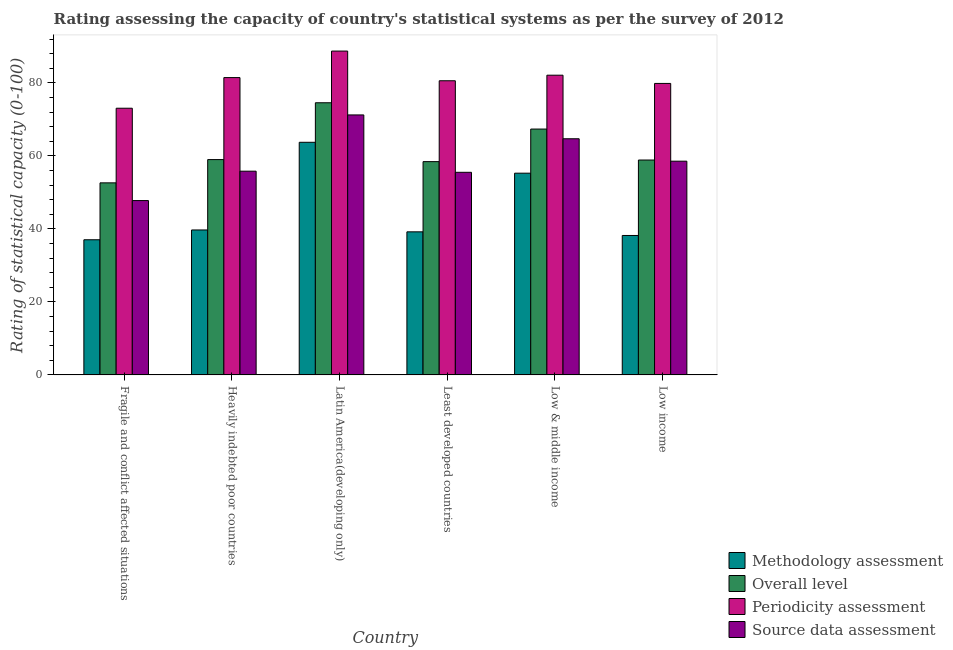How many groups of bars are there?
Provide a short and direct response. 6. How many bars are there on the 5th tick from the left?
Your response must be concise. 4. How many bars are there on the 3rd tick from the right?
Make the answer very short. 4. What is the methodology assessment rating in Least developed countries?
Your answer should be very brief. 39.21. Across all countries, what is the maximum overall level rating?
Offer a very short reply. 74.58. Across all countries, what is the minimum periodicity assessment rating?
Provide a succinct answer. 73.09. In which country was the overall level rating maximum?
Provide a succinct answer. Latin America(developing only). In which country was the periodicity assessment rating minimum?
Your response must be concise. Fragile and conflict affected situations. What is the total overall level rating in the graph?
Offer a terse response. 370.95. What is the difference between the methodology assessment rating in Fragile and conflict affected situations and that in Low & middle income?
Your answer should be very brief. -18.25. What is the difference between the methodology assessment rating in Low income and the overall level rating in Heavily indebted poor countries?
Offer a terse response. -20.8. What is the average overall level rating per country?
Ensure brevity in your answer.  61.82. What is the difference between the methodology assessment rating and source data assessment rating in Latin America(developing only)?
Your answer should be compact. -7.5. What is the ratio of the periodicity assessment rating in Heavily indebted poor countries to that in Latin America(developing only)?
Provide a short and direct response. 0.92. What is the difference between the highest and the second highest periodicity assessment rating?
Your answer should be very brief. 6.61. What is the difference between the highest and the lowest source data assessment rating?
Offer a terse response. 23.47. In how many countries, is the source data assessment rating greater than the average source data assessment rating taken over all countries?
Your answer should be very brief. 2. Is it the case that in every country, the sum of the overall level rating and methodology assessment rating is greater than the sum of source data assessment rating and periodicity assessment rating?
Offer a terse response. Yes. What does the 2nd bar from the left in Least developed countries represents?
Offer a very short reply. Overall level. What does the 3rd bar from the right in Heavily indebted poor countries represents?
Provide a succinct answer. Overall level. How many bars are there?
Keep it short and to the point. 24. How many countries are there in the graph?
Offer a very short reply. 6. What is the difference between two consecutive major ticks on the Y-axis?
Make the answer very short. 20. Does the graph contain any zero values?
Give a very brief answer. No. Does the graph contain grids?
Give a very brief answer. No. Where does the legend appear in the graph?
Provide a succinct answer. Bottom right. What is the title of the graph?
Your answer should be compact. Rating assessing the capacity of country's statistical systems as per the survey of 2012 . What is the label or title of the Y-axis?
Your answer should be very brief. Rating of statistical capacity (0-100). What is the Rating of statistical capacity (0-100) in Methodology assessment in Fragile and conflict affected situations?
Offer a very short reply. 37.04. What is the Rating of statistical capacity (0-100) of Overall level in Fragile and conflict affected situations?
Your answer should be very brief. 52.63. What is the Rating of statistical capacity (0-100) in Periodicity assessment in Fragile and conflict affected situations?
Provide a short and direct response. 73.09. What is the Rating of statistical capacity (0-100) of Source data assessment in Fragile and conflict affected situations?
Give a very brief answer. 47.78. What is the Rating of statistical capacity (0-100) of Methodology assessment in Heavily indebted poor countries?
Keep it short and to the point. 39.72. What is the Rating of statistical capacity (0-100) in Overall level in Heavily indebted poor countries?
Your answer should be compact. 59.01. What is the Rating of statistical capacity (0-100) in Periodicity assessment in Heavily indebted poor countries?
Your answer should be very brief. 81.48. What is the Rating of statistical capacity (0-100) in Source data assessment in Heavily indebted poor countries?
Your answer should be very brief. 55.83. What is the Rating of statistical capacity (0-100) of Methodology assessment in Latin America(developing only)?
Keep it short and to the point. 63.75. What is the Rating of statistical capacity (0-100) of Overall level in Latin America(developing only)?
Offer a terse response. 74.58. What is the Rating of statistical capacity (0-100) in Periodicity assessment in Latin America(developing only)?
Offer a terse response. 88.75. What is the Rating of statistical capacity (0-100) in Source data assessment in Latin America(developing only)?
Your response must be concise. 71.25. What is the Rating of statistical capacity (0-100) of Methodology assessment in Least developed countries?
Offer a terse response. 39.21. What is the Rating of statistical capacity (0-100) of Overall level in Least developed countries?
Your response must be concise. 58.45. What is the Rating of statistical capacity (0-100) of Periodicity assessment in Least developed countries?
Keep it short and to the point. 80.61. What is the Rating of statistical capacity (0-100) in Source data assessment in Least developed countries?
Provide a short and direct response. 55.53. What is the Rating of statistical capacity (0-100) of Methodology assessment in Low & middle income?
Your answer should be very brief. 55.28. What is the Rating of statistical capacity (0-100) of Overall level in Low & middle income?
Your answer should be very brief. 67.38. What is the Rating of statistical capacity (0-100) of Periodicity assessment in Low & middle income?
Your response must be concise. 82.14. What is the Rating of statistical capacity (0-100) in Source data assessment in Low & middle income?
Offer a terse response. 64.72. What is the Rating of statistical capacity (0-100) of Methodology assessment in Low income?
Make the answer very short. 38.21. What is the Rating of statistical capacity (0-100) in Overall level in Low income?
Keep it short and to the point. 58.89. What is the Rating of statistical capacity (0-100) in Periodicity assessment in Low income?
Offer a terse response. 79.88. What is the Rating of statistical capacity (0-100) of Source data assessment in Low income?
Provide a succinct answer. 58.57. Across all countries, what is the maximum Rating of statistical capacity (0-100) of Methodology assessment?
Your answer should be compact. 63.75. Across all countries, what is the maximum Rating of statistical capacity (0-100) of Overall level?
Your answer should be compact. 74.58. Across all countries, what is the maximum Rating of statistical capacity (0-100) in Periodicity assessment?
Provide a short and direct response. 88.75. Across all countries, what is the maximum Rating of statistical capacity (0-100) of Source data assessment?
Your answer should be very brief. 71.25. Across all countries, what is the minimum Rating of statistical capacity (0-100) in Methodology assessment?
Offer a very short reply. 37.04. Across all countries, what is the minimum Rating of statistical capacity (0-100) of Overall level?
Your response must be concise. 52.63. Across all countries, what is the minimum Rating of statistical capacity (0-100) of Periodicity assessment?
Provide a short and direct response. 73.09. Across all countries, what is the minimum Rating of statistical capacity (0-100) in Source data assessment?
Offer a terse response. 47.78. What is the total Rating of statistical capacity (0-100) of Methodology assessment in the graph?
Keep it short and to the point. 273.22. What is the total Rating of statistical capacity (0-100) of Overall level in the graph?
Provide a short and direct response. 370.95. What is the total Rating of statistical capacity (0-100) of Periodicity assessment in the graph?
Offer a very short reply. 485.95. What is the total Rating of statistical capacity (0-100) of Source data assessment in the graph?
Your answer should be very brief. 353.68. What is the difference between the Rating of statistical capacity (0-100) in Methodology assessment in Fragile and conflict affected situations and that in Heavily indebted poor countries?
Your response must be concise. -2.69. What is the difference between the Rating of statistical capacity (0-100) in Overall level in Fragile and conflict affected situations and that in Heavily indebted poor countries?
Provide a succinct answer. -6.38. What is the difference between the Rating of statistical capacity (0-100) in Periodicity assessment in Fragile and conflict affected situations and that in Heavily indebted poor countries?
Your answer should be very brief. -8.4. What is the difference between the Rating of statistical capacity (0-100) in Source data assessment in Fragile and conflict affected situations and that in Heavily indebted poor countries?
Keep it short and to the point. -8.06. What is the difference between the Rating of statistical capacity (0-100) of Methodology assessment in Fragile and conflict affected situations and that in Latin America(developing only)?
Provide a succinct answer. -26.71. What is the difference between the Rating of statistical capacity (0-100) in Overall level in Fragile and conflict affected situations and that in Latin America(developing only)?
Make the answer very short. -21.95. What is the difference between the Rating of statistical capacity (0-100) of Periodicity assessment in Fragile and conflict affected situations and that in Latin America(developing only)?
Provide a succinct answer. -15.66. What is the difference between the Rating of statistical capacity (0-100) of Source data assessment in Fragile and conflict affected situations and that in Latin America(developing only)?
Your answer should be very brief. -23.47. What is the difference between the Rating of statistical capacity (0-100) in Methodology assessment in Fragile and conflict affected situations and that in Least developed countries?
Keep it short and to the point. -2.17. What is the difference between the Rating of statistical capacity (0-100) in Overall level in Fragile and conflict affected situations and that in Least developed countries?
Ensure brevity in your answer.  -5.82. What is the difference between the Rating of statistical capacity (0-100) of Periodicity assessment in Fragile and conflict affected situations and that in Least developed countries?
Your response must be concise. -7.53. What is the difference between the Rating of statistical capacity (0-100) of Source data assessment in Fragile and conflict affected situations and that in Least developed countries?
Make the answer very short. -7.75. What is the difference between the Rating of statistical capacity (0-100) in Methodology assessment in Fragile and conflict affected situations and that in Low & middle income?
Your answer should be very brief. -18.25. What is the difference between the Rating of statistical capacity (0-100) in Overall level in Fragile and conflict affected situations and that in Low & middle income?
Keep it short and to the point. -14.75. What is the difference between the Rating of statistical capacity (0-100) of Periodicity assessment in Fragile and conflict affected situations and that in Low & middle income?
Offer a very short reply. -9.05. What is the difference between the Rating of statistical capacity (0-100) in Source data assessment in Fragile and conflict affected situations and that in Low & middle income?
Offer a terse response. -16.94. What is the difference between the Rating of statistical capacity (0-100) in Methodology assessment in Fragile and conflict affected situations and that in Low income?
Offer a terse response. -1.18. What is the difference between the Rating of statistical capacity (0-100) of Overall level in Fragile and conflict affected situations and that in Low income?
Your answer should be compact. -6.26. What is the difference between the Rating of statistical capacity (0-100) of Periodicity assessment in Fragile and conflict affected situations and that in Low income?
Offer a very short reply. -6.79. What is the difference between the Rating of statistical capacity (0-100) in Source data assessment in Fragile and conflict affected situations and that in Low income?
Make the answer very short. -10.79. What is the difference between the Rating of statistical capacity (0-100) in Methodology assessment in Heavily indebted poor countries and that in Latin America(developing only)?
Your response must be concise. -24.03. What is the difference between the Rating of statistical capacity (0-100) in Overall level in Heavily indebted poor countries and that in Latin America(developing only)?
Offer a very short reply. -15.57. What is the difference between the Rating of statistical capacity (0-100) in Periodicity assessment in Heavily indebted poor countries and that in Latin America(developing only)?
Your answer should be very brief. -7.27. What is the difference between the Rating of statistical capacity (0-100) of Source data assessment in Heavily indebted poor countries and that in Latin America(developing only)?
Give a very brief answer. -15.42. What is the difference between the Rating of statistical capacity (0-100) in Methodology assessment in Heavily indebted poor countries and that in Least developed countries?
Offer a terse response. 0.51. What is the difference between the Rating of statistical capacity (0-100) of Overall level in Heavily indebted poor countries and that in Least developed countries?
Give a very brief answer. 0.56. What is the difference between the Rating of statistical capacity (0-100) of Periodicity assessment in Heavily indebted poor countries and that in Least developed countries?
Provide a short and direct response. 0.87. What is the difference between the Rating of statistical capacity (0-100) in Source data assessment in Heavily indebted poor countries and that in Least developed countries?
Offer a terse response. 0.31. What is the difference between the Rating of statistical capacity (0-100) in Methodology assessment in Heavily indebted poor countries and that in Low & middle income?
Offer a terse response. -15.56. What is the difference between the Rating of statistical capacity (0-100) in Overall level in Heavily indebted poor countries and that in Low & middle income?
Offer a terse response. -8.37. What is the difference between the Rating of statistical capacity (0-100) in Periodicity assessment in Heavily indebted poor countries and that in Low & middle income?
Your answer should be compact. -0.66. What is the difference between the Rating of statistical capacity (0-100) of Source data assessment in Heavily indebted poor countries and that in Low & middle income?
Ensure brevity in your answer.  -8.88. What is the difference between the Rating of statistical capacity (0-100) in Methodology assessment in Heavily indebted poor countries and that in Low income?
Make the answer very short. 1.51. What is the difference between the Rating of statistical capacity (0-100) in Overall level in Heavily indebted poor countries and that in Low income?
Your answer should be very brief. 0.12. What is the difference between the Rating of statistical capacity (0-100) of Periodicity assessment in Heavily indebted poor countries and that in Low income?
Offer a very short reply. 1.6. What is the difference between the Rating of statistical capacity (0-100) in Source data assessment in Heavily indebted poor countries and that in Low income?
Your response must be concise. -2.74. What is the difference between the Rating of statistical capacity (0-100) of Methodology assessment in Latin America(developing only) and that in Least developed countries?
Your answer should be compact. 24.54. What is the difference between the Rating of statistical capacity (0-100) in Overall level in Latin America(developing only) and that in Least developed countries?
Your answer should be compact. 16.13. What is the difference between the Rating of statistical capacity (0-100) in Periodicity assessment in Latin America(developing only) and that in Least developed countries?
Your response must be concise. 8.14. What is the difference between the Rating of statistical capacity (0-100) of Source data assessment in Latin America(developing only) and that in Least developed countries?
Provide a short and direct response. 15.72. What is the difference between the Rating of statistical capacity (0-100) in Methodology assessment in Latin America(developing only) and that in Low & middle income?
Give a very brief answer. 8.47. What is the difference between the Rating of statistical capacity (0-100) of Overall level in Latin America(developing only) and that in Low & middle income?
Ensure brevity in your answer.  7.2. What is the difference between the Rating of statistical capacity (0-100) of Periodicity assessment in Latin America(developing only) and that in Low & middle income?
Your answer should be compact. 6.61. What is the difference between the Rating of statistical capacity (0-100) of Source data assessment in Latin America(developing only) and that in Low & middle income?
Give a very brief answer. 6.53. What is the difference between the Rating of statistical capacity (0-100) in Methodology assessment in Latin America(developing only) and that in Low income?
Keep it short and to the point. 25.54. What is the difference between the Rating of statistical capacity (0-100) in Overall level in Latin America(developing only) and that in Low income?
Provide a short and direct response. 15.69. What is the difference between the Rating of statistical capacity (0-100) of Periodicity assessment in Latin America(developing only) and that in Low income?
Your answer should be compact. 8.87. What is the difference between the Rating of statistical capacity (0-100) in Source data assessment in Latin America(developing only) and that in Low income?
Give a very brief answer. 12.68. What is the difference between the Rating of statistical capacity (0-100) of Methodology assessment in Least developed countries and that in Low & middle income?
Your answer should be very brief. -16.07. What is the difference between the Rating of statistical capacity (0-100) in Overall level in Least developed countries and that in Low & middle income?
Ensure brevity in your answer.  -8.93. What is the difference between the Rating of statistical capacity (0-100) in Periodicity assessment in Least developed countries and that in Low & middle income?
Provide a succinct answer. -1.52. What is the difference between the Rating of statistical capacity (0-100) of Source data assessment in Least developed countries and that in Low & middle income?
Your answer should be compact. -9.19. What is the difference between the Rating of statistical capacity (0-100) in Overall level in Least developed countries and that in Low income?
Offer a terse response. -0.44. What is the difference between the Rating of statistical capacity (0-100) in Periodicity assessment in Least developed countries and that in Low income?
Make the answer very short. 0.73. What is the difference between the Rating of statistical capacity (0-100) of Source data assessment in Least developed countries and that in Low income?
Offer a terse response. -3.05. What is the difference between the Rating of statistical capacity (0-100) in Methodology assessment in Low & middle income and that in Low income?
Your answer should be very brief. 17.07. What is the difference between the Rating of statistical capacity (0-100) in Overall level in Low & middle income and that in Low income?
Ensure brevity in your answer.  8.49. What is the difference between the Rating of statistical capacity (0-100) of Periodicity assessment in Low & middle income and that in Low income?
Provide a succinct answer. 2.26. What is the difference between the Rating of statistical capacity (0-100) in Source data assessment in Low & middle income and that in Low income?
Offer a terse response. 6.15. What is the difference between the Rating of statistical capacity (0-100) of Methodology assessment in Fragile and conflict affected situations and the Rating of statistical capacity (0-100) of Overall level in Heavily indebted poor countries?
Your answer should be compact. -21.98. What is the difference between the Rating of statistical capacity (0-100) in Methodology assessment in Fragile and conflict affected situations and the Rating of statistical capacity (0-100) in Periodicity assessment in Heavily indebted poor countries?
Ensure brevity in your answer.  -44.44. What is the difference between the Rating of statistical capacity (0-100) in Methodology assessment in Fragile and conflict affected situations and the Rating of statistical capacity (0-100) in Source data assessment in Heavily indebted poor countries?
Your answer should be very brief. -18.8. What is the difference between the Rating of statistical capacity (0-100) in Overall level in Fragile and conflict affected situations and the Rating of statistical capacity (0-100) in Periodicity assessment in Heavily indebted poor countries?
Offer a terse response. -28.85. What is the difference between the Rating of statistical capacity (0-100) of Overall level in Fragile and conflict affected situations and the Rating of statistical capacity (0-100) of Source data assessment in Heavily indebted poor countries?
Make the answer very short. -3.2. What is the difference between the Rating of statistical capacity (0-100) in Periodicity assessment in Fragile and conflict affected situations and the Rating of statistical capacity (0-100) in Source data assessment in Heavily indebted poor countries?
Ensure brevity in your answer.  17.25. What is the difference between the Rating of statistical capacity (0-100) in Methodology assessment in Fragile and conflict affected situations and the Rating of statistical capacity (0-100) in Overall level in Latin America(developing only)?
Offer a very short reply. -37.55. What is the difference between the Rating of statistical capacity (0-100) of Methodology assessment in Fragile and conflict affected situations and the Rating of statistical capacity (0-100) of Periodicity assessment in Latin America(developing only)?
Keep it short and to the point. -51.71. What is the difference between the Rating of statistical capacity (0-100) of Methodology assessment in Fragile and conflict affected situations and the Rating of statistical capacity (0-100) of Source data assessment in Latin America(developing only)?
Offer a terse response. -34.21. What is the difference between the Rating of statistical capacity (0-100) of Overall level in Fragile and conflict affected situations and the Rating of statistical capacity (0-100) of Periodicity assessment in Latin America(developing only)?
Offer a terse response. -36.12. What is the difference between the Rating of statistical capacity (0-100) in Overall level in Fragile and conflict affected situations and the Rating of statistical capacity (0-100) in Source data assessment in Latin America(developing only)?
Provide a short and direct response. -18.62. What is the difference between the Rating of statistical capacity (0-100) of Periodicity assessment in Fragile and conflict affected situations and the Rating of statistical capacity (0-100) of Source data assessment in Latin America(developing only)?
Provide a succinct answer. 1.84. What is the difference between the Rating of statistical capacity (0-100) in Methodology assessment in Fragile and conflict affected situations and the Rating of statistical capacity (0-100) in Overall level in Least developed countries?
Ensure brevity in your answer.  -21.41. What is the difference between the Rating of statistical capacity (0-100) of Methodology assessment in Fragile and conflict affected situations and the Rating of statistical capacity (0-100) of Periodicity assessment in Least developed countries?
Provide a short and direct response. -43.58. What is the difference between the Rating of statistical capacity (0-100) in Methodology assessment in Fragile and conflict affected situations and the Rating of statistical capacity (0-100) in Source data assessment in Least developed countries?
Provide a succinct answer. -18.49. What is the difference between the Rating of statistical capacity (0-100) in Overall level in Fragile and conflict affected situations and the Rating of statistical capacity (0-100) in Periodicity assessment in Least developed countries?
Keep it short and to the point. -27.98. What is the difference between the Rating of statistical capacity (0-100) in Overall level in Fragile and conflict affected situations and the Rating of statistical capacity (0-100) in Source data assessment in Least developed countries?
Ensure brevity in your answer.  -2.89. What is the difference between the Rating of statistical capacity (0-100) in Periodicity assessment in Fragile and conflict affected situations and the Rating of statistical capacity (0-100) in Source data assessment in Least developed countries?
Provide a succinct answer. 17.56. What is the difference between the Rating of statistical capacity (0-100) of Methodology assessment in Fragile and conflict affected situations and the Rating of statistical capacity (0-100) of Overall level in Low & middle income?
Give a very brief answer. -30.34. What is the difference between the Rating of statistical capacity (0-100) in Methodology assessment in Fragile and conflict affected situations and the Rating of statistical capacity (0-100) in Periodicity assessment in Low & middle income?
Your response must be concise. -45.1. What is the difference between the Rating of statistical capacity (0-100) of Methodology assessment in Fragile and conflict affected situations and the Rating of statistical capacity (0-100) of Source data assessment in Low & middle income?
Offer a very short reply. -27.68. What is the difference between the Rating of statistical capacity (0-100) in Overall level in Fragile and conflict affected situations and the Rating of statistical capacity (0-100) in Periodicity assessment in Low & middle income?
Make the answer very short. -29.5. What is the difference between the Rating of statistical capacity (0-100) of Overall level in Fragile and conflict affected situations and the Rating of statistical capacity (0-100) of Source data assessment in Low & middle income?
Your response must be concise. -12.08. What is the difference between the Rating of statistical capacity (0-100) of Periodicity assessment in Fragile and conflict affected situations and the Rating of statistical capacity (0-100) of Source data assessment in Low & middle income?
Provide a short and direct response. 8.37. What is the difference between the Rating of statistical capacity (0-100) of Methodology assessment in Fragile and conflict affected situations and the Rating of statistical capacity (0-100) of Overall level in Low income?
Provide a succinct answer. -21.85. What is the difference between the Rating of statistical capacity (0-100) of Methodology assessment in Fragile and conflict affected situations and the Rating of statistical capacity (0-100) of Periodicity assessment in Low income?
Offer a terse response. -42.84. What is the difference between the Rating of statistical capacity (0-100) of Methodology assessment in Fragile and conflict affected situations and the Rating of statistical capacity (0-100) of Source data assessment in Low income?
Your response must be concise. -21.53. What is the difference between the Rating of statistical capacity (0-100) of Overall level in Fragile and conflict affected situations and the Rating of statistical capacity (0-100) of Periodicity assessment in Low income?
Your answer should be very brief. -27.25. What is the difference between the Rating of statistical capacity (0-100) in Overall level in Fragile and conflict affected situations and the Rating of statistical capacity (0-100) in Source data assessment in Low income?
Keep it short and to the point. -5.94. What is the difference between the Rating of statistical capacity (0-100) in Periodicity assessment in Fragile and conflict affected situations and the Rating of statistical capacity (0-100) in Source data assessment in Low income?
Offer a very short reply. 14.52. What is the difference between the Rating of statistical capacity (0-100) in Methodology assessment in Heavily indebted poor countries and the Rating of statistical capacity (0-100) in Overall level in Latin America(developing only)?
Provide a succinct answer. -34.86. What is the difference between the Rating of statistical capacity (0-100) of Methodology assessment in Heavily indebted poor countries and the Rating of statistical capacity (0-100) of Periodicity assessment in Latin America(developing only)?
Give a very brief answer. -49.03. What is the difference between the Rating of statistical capacity (0-100) of Methodology assessment in Heavily indebted poor countries and the Rating of statistical capacity (0-100) of Source data assessment in Latin America(developing only)?
Your answer should be compact. -31.53. What is the difference between the Rating of statistical capacity (0-100) of Overall level in Heavily indebted poor countries and the Rating of statistical capacity (0-100) of Periodicity assessment in Latin America(developing only)?
Your response must be concise. -29.74. What is the difference between the Rating of statistical capacity (0-100) in Overall level in Heavily indebted poor countries and the Rating of statistical capacity (0-100) in Source data assessment in Latin America(developing only)?
Your response must be concise. -12.24. What is the difference between the Rating of statistical capacity (0-100) in Periodicity assessment in Heavily indebted poor countries and the Rating of statistical capacity (0-100) in Source data assessment in Latin America(developing only)?
Your response must be concise. 10.23. What is the difference between the Rating of statistical capacity (0-100) of Methodology assessment in Heavily indebted poor countries and the Rating of statistical capacity (0-100) of Overall level in Least developed countries?
Provide a succinct answer. -18.73. What is the difference between the Rating of statistical capacity (0-100) in Methodology assessment in Heavily indebted poor countries and the Rating of statistical capacity (0-100) in Periodicity assessment in Least developed countries?
Your answer should be compact. -40.89. What is the difference between the Rating of statistical capacity (0-100) in Methodology assessment in Heavily indebted poor countries and the Rating of statistical capacity (0-100) in Source data assessment in Least developed countries?
Provide a succinct answer. -15.8. What is the difference between the Rating of statistical capacity (0-100) of Overall level in Heavily indebted poor countries and the Rating of statistical capacity (0-100) of Periodicity assessment in Least developed countries?
Offer a terse response. -21.6. What is the difference between the Rating of statistical capacity (0-100) in Overall level in Heavily indebted poor countries and the Rating of statistical capacity (0-100) in Source data assessment in Least developed countries?
Provide a short and direct response. 3.49. What is the difference between the Rating of statistical capacity (0-100) of Periodicity assessment in Heavily indebted poor countries and the Rating of statistical capacity (0-100) of Source data assessment in Least developed countries?
Provide a short and direct response. 25.96. What is the difference between the Rating of statistical capacity (0-100) in Methodology assessment in Heavily indebted poor countries and the Rating of statistical capacity (0-100) in Overall level in Low & middle income?
Provide a succinct answer. -27.66. What is the difference between the Rating of statistical capacity (0-100) of Methodology assessment in Heavily indebted poor countries and the Rating of statistical capacity (0-100) of Periodicity assessment in Low & middle income?
Ensure brevity in your answer.  -42.42. What is the difference between the Rating of statistical capacity (0-100) of Methodology assessment in Heavily indebted poor countries and the Rating of statistical capacity (0-100) of Source data assessment in Low & middle income?
Provide a succinct answer. -24.99. What is the difference between the Rating of statistical capacity (0-100) of Overall level in Heavily indebted poor countries and the Rating of statistical capacity (0-100) of Periodicity assessment in Low & middle income?
Give a very brief answer. -23.13. What is the difference between the Rating of statistical capacity (0-100) of Overall level in Heavily indebted poor countries and the Rating of statistical capacity (0-100) of Source data assessment in Low & middle income?
Provide a short and direct response. -5.7. What is the difference between the Rating of statistical capacity (0-100) of Periodicity assessment in Heavily indebted poor countries and the Rating of statistical capacity (0-100) of Source data assessment in Low & middle income?
Your response must be concise. 16.76. What is the difference between the Rating of statistical capacity (0-100) in Methodology assessment in Heavily indebted poor countries and the Rating of statistical capacity (0-100) in Overall level in Low income?
Make the answer very short. -19.17. What is the difference between the Rating of statistical capacity (0-100) in Methodology assessment in Heavily indebted poor countries and the Rating of statistical capacity (0-100) in Periodicity assessment in Low income?
Give a very brief answer. -40.16. What is the difference between the Rating of statistical capacity (0-100) in Methodology assessment in Heavily indebted poor countries and the Rating of statistical capacity (0-100) in Source data assessment in Low income?
Your response must be concise. -18.85. What is the difference between the Rating of statistical capacity (0-100) of Overall level in Heavily indebted poor countries and the Rating of statistical capacity (0-100) of Periodicity assessment in Low income?
Your response must be concise. -20.87. What is the difference between the Rating of statistical capacity (0-100) of Overall level in Heavily indebted poor countries and the Rating of statistical capacity (0-100) of Source data assessment in Low income?
Offer a very short reply. 0.44. What is the difference between the Rating of statistical capacity (0-100) in Periodicity assessment in Heavily indebted poor countries and the Rating of statistical capacity (0-100) in Source data assessment in Low income?
Your answer should be very brief. 22.91. What is the difference between the Rating of statistical capacity (0-100) of Methodology assessment in Latin America(developing only) and the Rating of statistical capacity (0-100) of Overall level in Least developed countries?
Your answer should be compact. 5.3. What is the difference between the Rating of statistical capacity (0-100) of Methodology assessment in Latin America(developing only) and the Rating of statistical capacity (0-100) of Periodicity assessment in Least developed countries?
Offer a very short reply. -16.86. What is the difference between the Rating of statistical capacity (0-100) of Methodology assessment in Latin America(developing only) and the Rating of statistical capacity (0-100) of Source data assessment in Least developed countries?
Give a very brief answer. 8.22. What is the difference between the Rating of statistical capacity (0-100) of Overall level in Latin America(developing only) and the Rating of statistical capacity (0-100) of Periodicity assessment in Least developed countries?
Ensure brevity in your answer.  -6.03. What is the difference between the Rating of statistical capacity (0-100) in Overall level in Latin America(developing only) and the Rating of statistical capacity (0-100) in Source data assessment in Least developed countries?
Make the answer very short. 19.06. What is the difference between the Rating of statistical capacity (0-100) in Periodicity assessment in Latin America(developing only) and the Rating of statistical capacity (0-100) in Source data assessment in Least developed countries?
Offer a terse response. 33.22. What is the difference between the Rating of statistical capacity (0-100) of Methodology assessment in Latin America(developing only) and the Rating of statistical capacity (0-100) of Overall level in Low & middle income?
Provide a short and direct response. -3.63. What is the difference between the Rating of statistical capacity (0-100) of Methodology assessment in Latin America(developing only) and the Rating of statistical capacity (0-100) of Periodicity assessment in Low & middle income?
Provide a succinct answer. -18.39. What is the difference between the Rating of statistical capacity (0-100) in Methodology assessment in Latin America(developing only) and the Rating of statistical capacity (0-100) in Source data assessment in Low & middle income?
Offer a very short reply. -0.97. What is the difference between the Rating of statistical capacity (0-100) of Overall level in Latin America(developing only) and the Rating of statistical capacity (0-100) of Periodicity assessment in Low & middle income?
Keep it short and to the point. -7.55. What is the difference between the Rating of statistical capacity (0-100) in Overall level in Latin America(developing only) and the Rating of statistical capacity (0-100) in Source data assessment in Low & middle income?
Your answer should be very brief. 9.87. What is the difference between the Rating of statistical capacity (0-100) of Periodicity assessment in Latin America(developing only) and the Rating of statistical capacity (0-100) of Source data assessment in Low & middle income?
Give a very brief answer. 24.03. What is the difference between the Rating of statistical capacity (0-100) of Methodology assessment in Latin America(developing only) and the Rating of statistical capacity (0-100) of Overall level in Low income?
Provide a short and direct response. 4.86. What is the difference between the Rating of statistical capacity (0-100) in Methodology assessment in Latin America(developing only) and the Rating of statistical capacity (0-100) in Periodicity assessment in Low income?
Make the answer very short. -16.13. What is the difference between the Rating of statistical capacity (0-100) of Methodology assessment in Latin America(developing only) and the Rating of statistical capacity (0-100) of Source data assessment in Low income?
Offer a very short reply. 5.18. What is the difference between the Rating of statistical capacity (0-100) in Overall level in Latin America(developing only) and the Rating of statistical capacity (0-100) in Periodicity assessment in Low income?
Ensure brevity in your answer.  -5.3. What is the difference between the Rating of statistical capacity (0-100) of Overall level in Latin America(developing only) and the Rating of statistical capacity (0-100) of Source data assessment in Low income?
Ensure brevity in your answer.  16.01. What is the difference between the Rating of statistical capacity (0-100) in Periodicity assessment in Latin America(developing only) and the Rating of statistical capacity (0-100) in Source data assessment in Low income?
Ensure brevity in your answer.  30.18. What is the difference between the Rating of statistical capacity (0-100) of Methodology assessment in Least developed countries and the Rating of statistical capacity (0-100) of Overall level in Low & middle income?
Your answer should be very brief. -28.17. What is the difference between the Rating of statistical capacity (0-100) of Methodology assessment in Least developed countries and the Rating of statistical capacity (0-100) of Periodicity assessment in Low & middle income?
Provide a short and direct response. -42.93. What is the difference between the Rating of statistical capacity (0-100) of Methodology assessment in Least developed countries and the Rating of statistical capacity (0-100) of Source data assessment in Low & middle income?
Offer a very short reply. -25.51. What is the difference between the Rating of statistical capacity (0-100) in Overall level in Least developed countries and the Rating of statistical capacity (0-100) in Periodicity assessment in Low & middle income?
Give a very brief answer. -23.69. What is the difference between the Rating of statistical capacity (0-100) in Overall level in Least developed countries and the Rating of statistical capacity (0-100) in Source data assessment in Low & middle income?
Your answer should be very brief. -6.27. What is the difference between the Rating of statistical capacity (0-100) of Periodicity assessment in Least developed countries and the Rating of statistical capacity (0-100) of Source data assessment in Low & middle income?
Offer a terse response. 15.9. What is the difference between the Rating of statistical capacity (0-100) of Methodology assessment in Least developed countries and the Rating of statistical capacity (0-100) of Overall level in Low income?
Offer a terse response. -19.68. What is the difference between the Rating of statistical capacity (0-100) in Methodology assessment in Least developed countries and the Rating of statistical capacity (0-100) in Periodicity assessment in Low income?
Your answer should be very brief. -40.67. What is the difference between the Rating of statistical capacity (0-100) of Methodology assessment in Least developed countries and the Rating of statistical capacity (0-100) of Source data assessment in Low income?
Make the answer very short. -19.36. What is the difference between the Rating of statistical capacity (0-100) of Overall level in Least developed countries and the Rating of statistical capacity (0-100) of Periodicity assessment in Low income?
Give a very brief answer. -21.43. What is the difference between the Rating of statistical capacity (0-100) of Overall level in Least developed countries and the Rating of statistical capacity (0-100) of Source data assessment in Low income?
Your answer should be compact. -0.12. What is the difference between the Rating of statistical capacity (0-100) in Periodicity assessment in Least developed countries and the Rating of statistical capacity (0-100) in Source data assessment in Low income?
Keep it short and to the point. 22.04. What is the difference between the Rating of statistical capacity (0-100) of Methodology assessment in Low & middle income and the Rating of statistical capacity (0-100) of Overall level in Low income?
Your answer should be compact. -3.61. What is the difference between the Rating of statistical capacity (0-100) of Methodology assessment in Low & middle income and the Rating of statistical capacity (0-100) of Periodicity assessment in Low income?
Keep it short and to the point. -24.6. What is the difference between the Rating of statistical capacity (0-100) in Methodology assessment in Low & middle income and the Rating of statistical capacity (0-100) in Source data assessment in Low income?
Give a very brief answer. -3.29. What is the difference between the Rating of statistical capacity (0-100) of Overall level in Low & middle income and the Rating of statistical capacity (0-100) of Periodicity assessment in Low income?
Keep it short and to the point. -12.5. What is the difference between the Rating of statistical capacity (0-100) of Overall level in Low & middle income and the Rating of statistical capacity (0-100) of Source data assessment in Low income?
Offer a very short reply. 8.81. What is the difference between the Rating of statistical capacity (0-100) in Periodicity assessment in Low & middle income and the Rating of statistical capacity (0-100) in Source data assessment in Low income?
Your answer should be very brief. 23.57. What is the average Rating of statistical capacity (0-100) in Methodology assessment per country?
Provide a short and direct response. 45.54. What is the average Rating of statistical capacity (0-100) in Overall level per country?
Your answer should be compact. 61.82. What is the average Rating of statistical capacity (0-100) of Periodicity assessment per country?
Make the answer very short. 80.99. What is the average Rating of statistical capacity (0-100) in Source data assessment per country?
Your response must be concise. 58.95. What is the difference between the Rating of statistical capacity (0-100) in Methodology assessment and Rating of statistical capacity (0-100) in Overall level in Fragile and conflict affected situations?
Provide a short and direct response. -15.6. What is the difference between the Rating of statistical capacity (0-100) in Methodology assessment and Rating of statistical capacity (0-100) in Periodicity assessment in Fragile and conflict affected situations?
Ensure brevity in your answer.  -36.05. What is the difference between the Rating of statistical capacity (0-100) in Methodology assessment and Rating of statistical capacity (0-100) in Source data assessment in Fragile and conflict affected situations?
Offer a very short reply. -10.74. What is the difference between the Rating of statistical capacity (0-100) of Overall level and Rating of statistical capacity (0-100) of Periodicity assessment in Fragile and conflict affected situations?
Make the answer very short. -20.45. What is the difference between the Rating of statistical capacity (0-100) in Overall level and Rating of statistical capacity (0-100) in Source data assessment in Fragile and conflict affected situations?
Offer a very short reply. 4.86. What is the difference between the Rating of statistical capacity (0-100) of Periodicity assessment and Rating of statistical capacity (0-100) of Source data assessment in Fragile and conflict affected situations?
Make the answer very short. 25.31. What is the difference between the Rating of statistical capacity (0-100) of Methodology assessment and Rating of statistical capacity (0-100) of Overall level in Heavily indebted poor countries?
Ensure brevity in your answer.  -19.29. What is the difference between the Rating of statistical capacity (0-100) in Methodology assessment and Rating of statistical capacity (0-100) in Periodicity assessment in Heavily indebted poor countries?
Provide a short and direct response. -41.76. What is the difference between the Rating of statistical capacity (0-100) of Methodology assessment and Rating of statistical capacity (0-100) of Source data assessment in Heavily indebted poor countries?
Provide a succinct answer. -16.11. What is the difference between the Rating of statistical capacity (0-100) of Overall level and Rating of statistical capacity (0-100) of Periodicity assessment in Heavily indebted poor countries?
Keep it short and to the point. -22.47. What is the difference between the Rating of statistical capacity (0-100) in Overall level and Rating of statistical capacity (0-100) in Source data assessment in Heavily indebted poor countries?
Make the answer very short. 3.18. What is the difference between the Rating of statistical capacity (0-100) in Periodicity assessment and Rating of statistical capacity (0-100) in Source data assessment in Heavily indebted poor countries?
Provide a short and direct response. 25.65. What is the difference between the Rating of statistical capacity (0-100) of Methodology assessment and Rating of statistical capacity (0-100) of Overall level in Latin America(developing only)?
Make the answer very short. -10.83. What is the difference between the Rating of statistical capacity (0-100) of Methodology assessment and Rating of statistical capacity (0-100) of Periodicity assessment in Latin America(developing only)?
Offer a terse response. -25. What is the difference between the Rating of statistical capacity (0-100) in Methodology assessment and Rating of statistical capacity (0-100) in Source data assessment in Latin America(developing only)?
Give a very brief answer. -7.5. What is the difference between the Rating of statistical capacity (0-100) in Overall level and Rating of statistical capacity (0-100) in Periodicity assessment in Latin America(developing only)?
Provide a succinct answer. -14.17. What is the difference between the Rating of statistical capacity (0-100) of Overall level and Rating of statistical capacity (0-100) of Source data assessment in Latin America(developing only)?
Provide a short and direct response. 3.33. What is the difference between the Rating of statistical capacity (0-100) in Periodicity assessment and Rating of statistical capacity (0-100) in Source data assessment in Latin America(developing only)?
Offer a terse response. 17.5. What is the difference between the Rating of statistical capacity (0-100) of Methodology assessment and Rating of statistical capacity (0-100) of Overall level in Least developed countries?
Your answer should be compact. -19.24. What is the difference between the Rating of statistical capacity (0-100) in Methodology assessment and Rating of statistical capacity (0-100) in Periodicity assessment in Least developed countries?
Make the answer very short. -41.4. What is the difference between the Rating of statistical capacity (0-100) in Methodology assessment and Rating of statistical capacity (0-100) in Source data assessment in Least developed countries?
Provide a short and direct response. -16.32. What is the difference between the Rating of statistical capacity (0-100) of Overall level and Rating of statistical capacity (0-100) of Periodicity assessment in Least developed countries?
Provide a short and direct response. -22.16. What is the difference between the Rating of statistical capacity (0-100) of Overall level and Rating of statistical capacity (0-100) of Source data assessment in Least developed countries?
Offer a very short reply. 2.92. What is the difference between the Rating of statistical capacity (0-100) in Periodicity assessment and Rating of statistical capacity (0-100) in Source data assessment in Least developed countries?
Make the answer very short. 25.09. What is the difference between the Rating of statistical capacity (0-100) of Methodology assessment and Rating of statistical capacity (0-100) of Overall level in Low & middle income?
Your answer should be very brief. -12.1. What is the difference between the Rating of statistical capacity (0-100) of Methodology assessment and Rating of statistical capacity (0-100) of Periodicity assessment in Low & middle income?
Your answer should be very brief. -26.86. What is the difference between the Rating of statistical capacity (0-100) in Methodology assessment and Rating of statistical capacity (0-100) in Source data assessment in Low & middle income?
Provide a short and direct response. -9.43. What is the difference between the Rating of statistical capacity (0-100) in Overall level and Rating of statistical capacity (0-100) in Periodicity assessment in Low & middle income?
Ensure brevity in your answer.  -14.76. What is the difference between the Rating of statistical capacity (0-100) of Overall level and Rating of statistical capacity (0-100) of Source data assessment in Low & middle income?
Make the answer very short. 2.66. What is the difference between the Rating of statistical capacity (0-100) of Periodicity assessment and Rating of statistical capacity (0-100) of Source data assessment in Low & middle income?
Your response must be concise. 17.42. What is the difference between the Rating of statistical capacity (0-100) in Methodology assessment and Rating of statistical capacity (0-100) in Overall level in Low income?
Offer a terse response. -20.67. What is the difference between the Rating of statistical capacity (0-100) of Methodology assessment and Rating of statistical capacity (0-100) of Periodicity assessment in Low income?
Offer a very short reply. -41.67. What is the difference between the Rating of statistical capacity (0-100) in Methodology assessment and Rating of statistical capacity (0-100) in Source data assessment in Low income?
Your response must be concise. -20.36. What is the difference between the Rating of statistical capacity (0-100) in Overall level and Rating of statistical capacity (0-100) in Periodicity assessment in Low income?
Give a very brief answer. -20.99. What is the difference between the Rating of statistical capacity (0-100) of Overall level and Rating of statistical capacity (0-100) of Source data assessment in Low income?
Keep it short and to the point. 0.32. What is the difference between the Rating of statistical capacity (0-100) of Periodicity assessment and Rating of statistical capacity (0-100) of Source data assessment in Low income?
Provide a succinct answer. 21.31. What is the ratio of the Rating of statistical capacity (0-100) of Methodology assessment in Fragile and conflict affected situations to that in Heavily indebted poor countries?
Provide a short and direct response. 0.93. What is the ratio of the Rating of statistical capacity (0-100) in Overall level in Fragile and conflict affected situations to that in Heavily indebted poor countries?
Your answer should be very brief. 0.89. What is the ratio of the Rating of statistical capacity (0-100) of Periodicity assessment in Fragile and conflict affected situations to that in Heavily indebted poor countries?
Provide a short and direct response. 0.9. What is the ratio of the Rating of statistical capacity (0-100) of Source data assessment in Fragile and conflict affected situations to that in Heavily indebted poor countries?
Your answer should be compact. 0.86. What is the ratio of the Rating of statistical capacity (0-100) of Methodology assessment in Fragile and conflict affected situations to that in Latin America(developing only)?
Offer a terse response. 0.58. What is the ratio of the Rating of statistical capacity (0-100) in Overall level in Fragile and conflict affected situations to that in Latin America(developing only)?
Your answer should be very brief. 0.71. What is the ratio of the Rating of statistical capacity (0-100) in Periodicity assessment in Fragile and conflict affected situations to that in Latin America(developing only)?
Provide a succinct answer. 0.82. What is the ratio of the Rating of statistical capacity (0-100) in Source data assessment in Fragile and conflict affected situations to that in Latin America(developing only)?
Keep it short and to the point. 0.67. What is the ratio of the Rating of statistical capacity (0-100) of Methodology assessment in Fragile and conflict affected situations to that in Least developed countries?
Your answer should be compact. 0.94. What is the ratio of the Rating of statistical capacity (0-100) of Overall level in Fragile and conflict affected situations to that in Least developed countries?
Your answer should be compact. 0.9. What is the ratio of the Rating of statistical capacity (0-100) in Periodicity assessment in Fragile and conflict affected situations to that in Least developed countries?
Offer a terse response. 0.91. What is the ratio of the Rating of statistical capacity (0-100) in Source data assessment in Fragile and conflict affected situations to that in Least developed countries?
Keep it short and to the point. 0.86. What is the ratio of the Rating of statistical capacity (0-100) of Methodology assessment in Fragile and conflict affected situations to that in Low & middle income?
Your response must be concise. 0.67. What is the ratio of the Rating of statistical capacity (0-100) of Overall level in Fragile and conflict affected situations to that in Low & middle income?
Provide a succinct answer. 0.78. What is the ratio of the Rating of statistical capacity (0-100) of Periodicity assessment in Fragile and conflict affected situations to that in Low & middle income?
Your answer should be compact. 0.89. What is the ratio of the Rating of statistical capacity (0-100) in Source data assessment in Fragile and conflict affected situations to that in Low & middle income?
Ensure brevity in your answer.  0.74. What is the ratio of the Rating of statistical capacity (0-100) of Methodology assessment in Fragile and conflict affected situations to that in Low income?
Your answer should be compact. 0.97. What is the ratio of the Rating of statistical capacity (0-100) of Overall level in Fragile and conflict affected situations to that in Low income?
Provide a succinct answer. 0.89. What is the ratio of the Rating of statistical capacity (0-100) in Periodicity assessment in Fragile and conflict affected situations to that in Low income?
Offer a very short reply. 0.91. What is the ratio of the Rating of statistical capacity (0-100) in Source data assessment in Fragile and conflict affected situations to that in Low income?
Provide a short and direct response. 0.82. What is the ratio of the Rating of statistical capacity (0-100) of Methodology assessment in Heavily indebted poor countries to that in Latin America(developing only)?
Your response must be concise. 0.62. What is the ratio of the Rating of statistical capacity (0-100) in Overall level in Heavily indebted poor countries to that in Latin America(developing only)?
Keep it short and to the point. 0.79. What is the ratio of the Rating of statistical capacity (0-100) in Periodicity assessment in Heavily indebted poor countries to that in Latin America(developing only)?
Offer a very short reply. 0.92. What is the ratio of the Rating of statistical capacity (0-100) of Source data assessment in Heavily indebted poor countries to that in Latin America(developing only)?
Provide a succinct answer. 0.78. What is the ratio of the Rating of statistical capacity (0-100) of Methodology assessment in Heavily indebted poor countries to that in Least developed countries?
Your answer should be very brief. 1.01. What is the ratio of the Rating of statistical capacity (0-100) of Overall level in Heavily indebted poor countries to that in Least developed countries?
Keep it short and to the point. 1.01. What is the ratio of the Rating of statistical capacity (0-100) in Periodicity assessment in Heavily indebted poor countries to that in Least developed countries?
Provide a succinct answer. 1.01. What is the ratio of the Rating of statistical capacity (0-100) in Methodology assessment in Heavily indebted poor countries to that in Low & middle income?
Offer a very short reply. 0.72. What is the ratio of the Rating of statistical capacity (0-100) in Overall level in Heavily indebted poor countries to that in Low & middle income?
Offer a very short reply. 0.88. What is the ratio of the Rating of statistical capacity (0-100) in Source data assessment in Heavily indebted poor countries to that in Low & middle income?
Give a very brief answer. 0.86. What is the ratio of the Rating of statistical capacity (0-100) in Methodology assessment in Heavily indebted poor countries to that in Low income?
Offer a terse response. 1.04. What is the ratio of the Rating of statistical capacity (0-100) of Overall level in Heavily indebted poor countries to that in Low income?
Your response must be concise. 1. What is the ratio of the Rating of statistical capacity (0-100) in Source data assessment in Heavily indebted poor countries to that in Low income?
Offer a very short reply. 0.95. What is the ratio of the Rating of statistical capacity (0-100) in Methodology assessment in Latin America(developing only) to that in Least developed countries?
Keep it short and to the point. 1.63. What is the ratio of the Rating of statistical capacity (0-100) of Overall level in Latin America(developing only) to that in Least developed countries?
Your answer should be very brief. 1.28. What is the ratio of the Rating of statistical capacity (0-100) of Periodicity assessment in Latin America(developing only) to that in Least developed countries?
Give a very brief answer. 1.1. What is the ratio of the Rating of statistical capacity (0-100) in Source data assessment in Latin America(developing only) to that in Least developed countries?
Give a very brief answer. 1.28. What is the ratio of the Rating of statistical capacity (0-100) in Methodology assessment in Latin America(developing only) to that in Low & middle income?
Keep it short and to the point. 1.15. What is the ratio of the Rating of statistical capacity (0-100) in Overall level in Latin America(developing only) to that in Low & middle income?
Your response must be concise. 1.11. What is the ratio of the Rating of statistical capacity (0-100) in Periodicity assessment in Latin America(developing only) to that in Low & middle income?
Your response must be concise. 1.08. What is the ratio of the Rating of statistical capacity (0-100) in Source data assessment in Latin America(developing only) to that in Low & middle income?
Your response must be concise. 1.1. What is the ratio of the Rating of statistical capacity (0-100) of Methodology assessment in Latin America(developing only) to that in Low income?
Make the answer very short. 1.67. What is the ratio of the Rating of statistical capacity (0-100) of Overall level in Latin America(developing only) to that in Low income?
Offer a very short reply. 1.27. What is the ratio of the Rating of statistical capacity (0-100) in Periodicity assessment in Latin America(developing only) to that in Low income?
Give a very brief answer. 1.11. What is the ratio of the Rating of statistical capacity (0-100) of Source data assessment in Latin America(developing only) to that in Low income?
Your answer should be compact. 1.22. What is the ratio of the Rating of statistical capacity (0-100) in Methodology assessment in Least developed countries to that in Low & middle income?
Ensure brevity in your answer.  0.71. What is the ratio of the Rating of statistical capacity (0-100) of Overall level in Least developed countries to that in Low & middle income?
Provide a succinct answer. 0.87. What is the ratio of the Rating of statistical capacity (0-100) in Periodicity assessment in Least developed countries to that in Low & middle income?
Your answer should be compact. 0.98. What is the ratio of the Rating of statistical capacity (0-100) in Source data assessment in Least developed countries to that in Low & middle income?
Give a very brief answer. 0.86. What is the ratio of the Rating of statistical capacity (0-100) in Methodology assessment in Least developed countries to that in Low income?
Your answer should be compact. 1.03. What is the ratio of the Rating of statistical capacity (0-100) of Periodicity assessment in Least developed countries to that in Low income?
Provide a short and direct response. 1.01. What is the ratio of the Rating of statistical capacity (0-100) of Source data assessment in Least developed countries to that in Low income?
Offer a terse response. 0.95. What is the ratio of the Rating of statistical capacity (0-100) of Methodology assessment in Low & middle income to that in Low income?
Your response must be concise. 1.45. What is the ratio of the Rating of statistical capacity (0-100) in Overall level in Low & middle income to that in Low income?
Make the answer very short. 1.14. What is the ratio of the Rating of statistical capacity (0-100) of Periodicity assessment in Low & middle income to that in Low income?
Give a very brief answer. 1.03. What is the ratio of the Rating of statistical capacity (0-100) of Source data assessment in Low & middle income to that in Low income?
Provide a succinct answer. 1.1. What is the difference between the highest and the second highest Rating of statistical capacity (0-100) in Methodology assessment?
Your response must be concise. 8.47. What is the difference between the highest and the second highest Rating of statistical capacity (0-100) in Overall level?
Your answer should be compact. 7.2. What is the difference between the highest and the second highest Rating of statistical capacity (0-100) of Periodicity assessment?
Offer a very short reply. 6.61. What is the difference between the highest and the second highest Rating of statistical capacity (0-100) of Source data assessment?
Give a very brief answer. 6.53. What is the difference between the highest and the lowest Rating of statistical capacity (0-100) in Methodology assessment?
Provide a succinct answer. 26.71. What is the difference between the highest and the lowest Rating of statistical capacity (0-100) in Overall level?
Ensure brevity in your answer.  21.95. What is the difference between the highest and the lowest Rating of statistical capacity (0-100) of Periodicity assessment?
Your answer should be compact. 15.66. What is the difference between the highest and the lowest Rating of statistical capacity (0-100) of Source data assessment?
Provide a succinct answer. 23.47. 